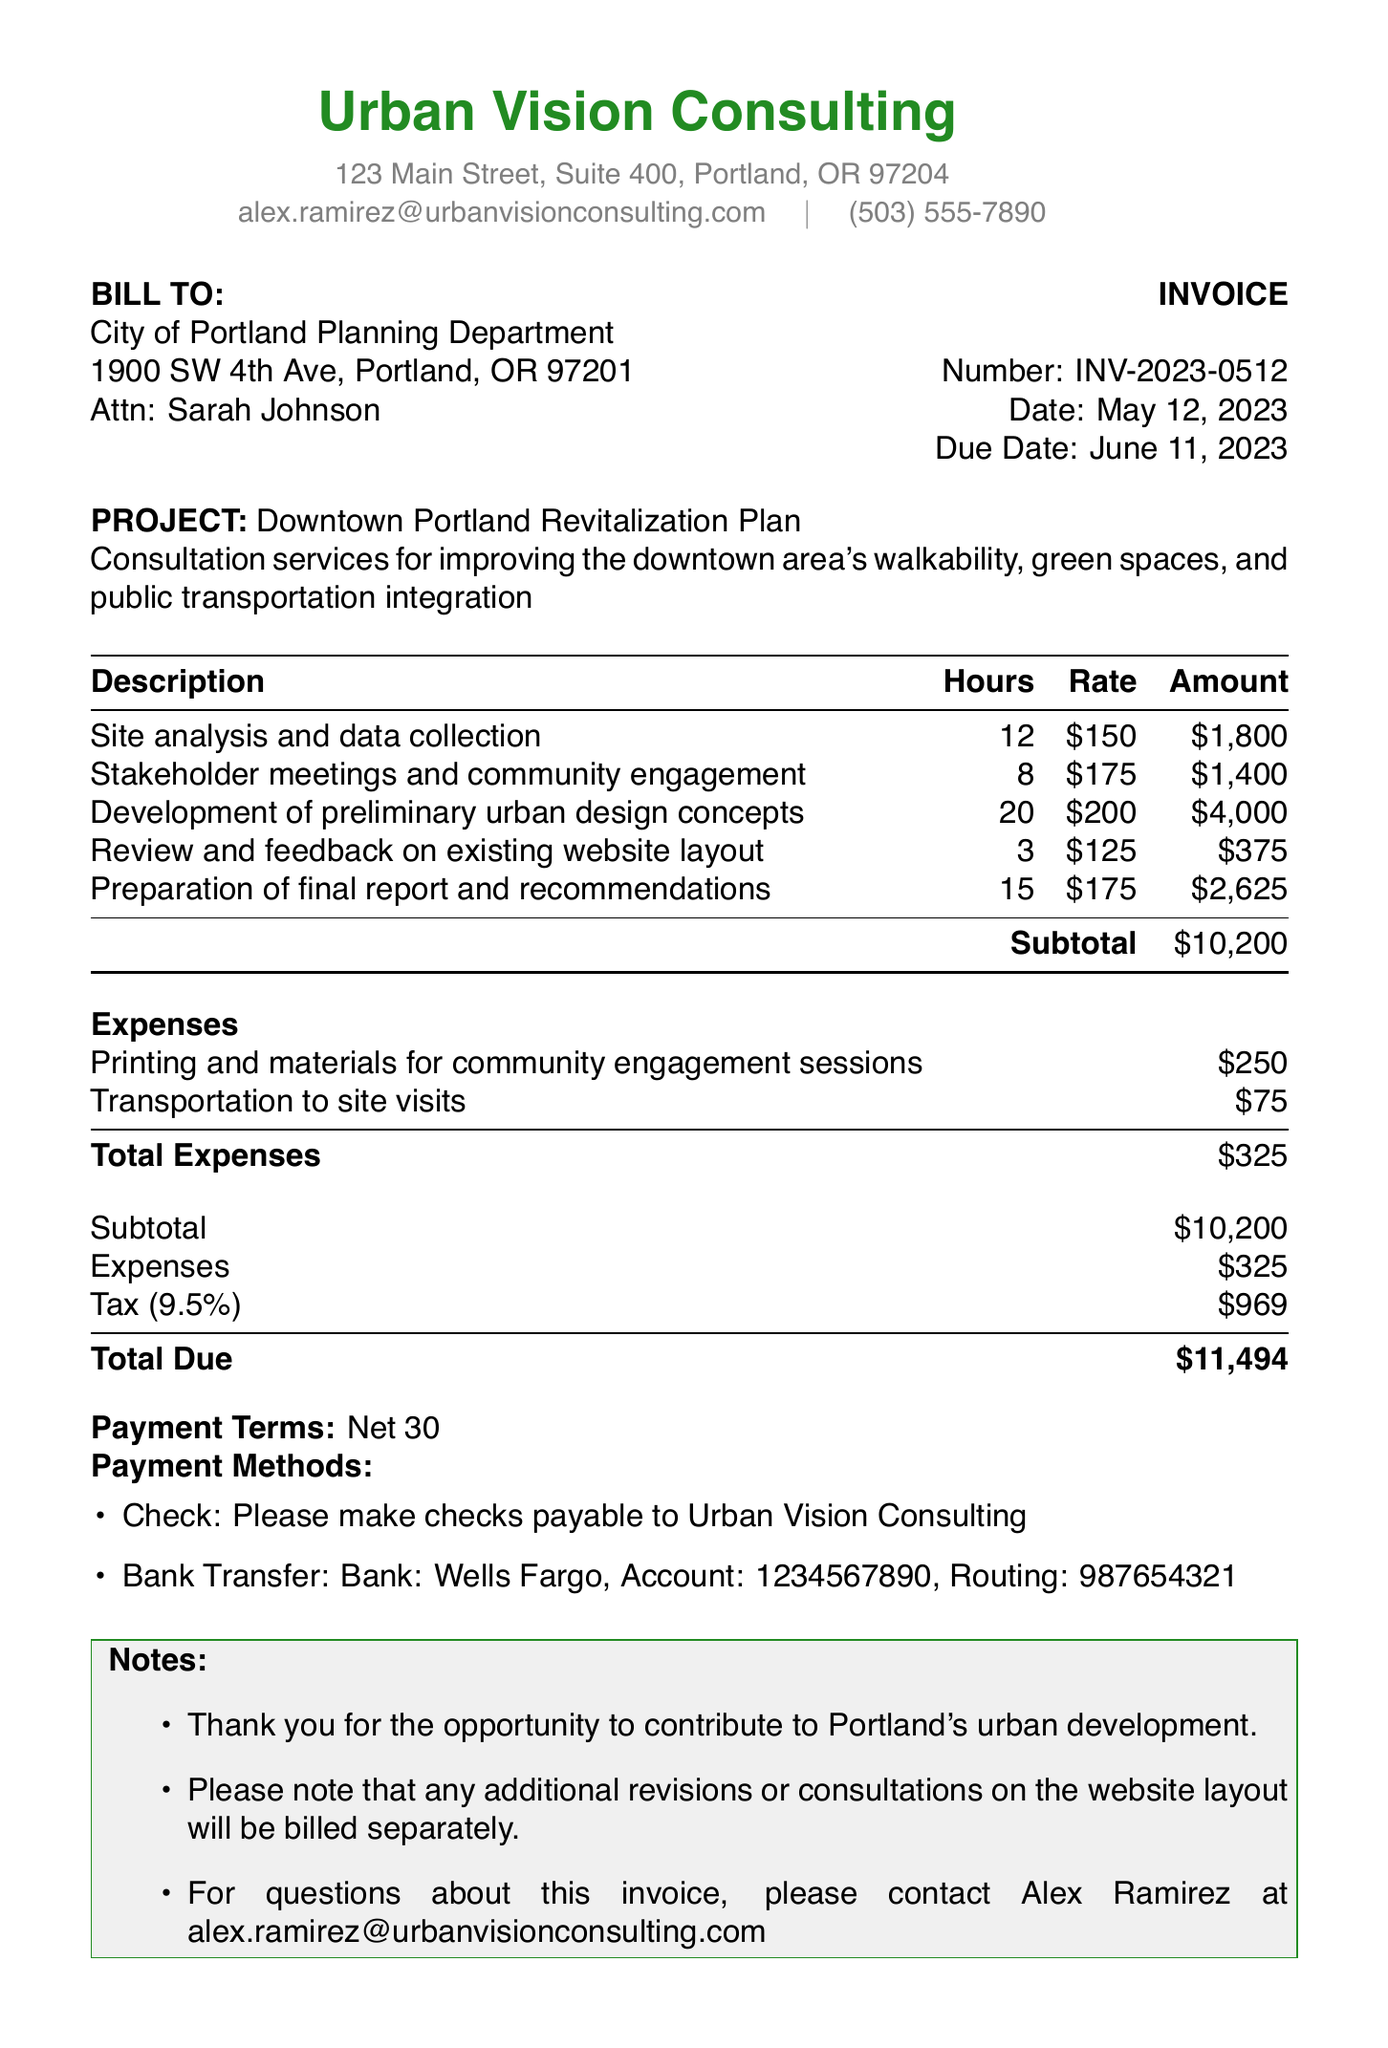what is the invoice number? The invoice number is mentioned at the top of the document, which is used for identification purposes.
Answer: INV-2023-0512 who issued the invoice? The 'Consultant' section specifies who provided the consultation services and issued the invoice.
Answer: Alex Ramirez what is the total amount due? The total amount due is calculated at the end of the invoice and reflects all services and expenses.
Answer: 11494 how many hours were billed for stakeholder meetings? The specific service description includes the number of hours billed for that task.
Answer: 8 what is the tax rate applied to the invoice? The tax rate is itemized in the summary section of the invoice, showing the applicable charge to the subtotal.
Answer: 9.5% what is the main project described in this invoice? The project name is explicitly stated in the project section of the document, summarizing the consultation purpose.
Answer: Downtown Portland Revitalization Plan what was the cost for the review and feedback on the website layout? The invoice itemization provides the specific total amount charged for that service.
Answer: 375 how much was spent on transportation to site visits? The expenses section lists all additional costs incurred for the project and their respective amounts.
Answer: 75 what are the payment terms listed in the invoice? Payment terms are defined in a specific section of the document to inform the client of the due timeframe.
Answer: Net 30 